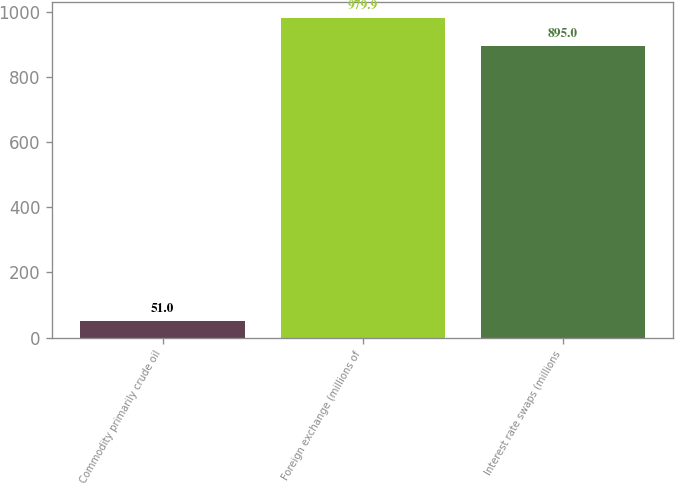Convert chart. <chart><loc_0><loc_0><loc_500><loc_500><bar_chart><fcel>Commodity primarily crude oil<fcel>Foreign exchange (millions of<fcel>Interest rate swaps (millions<nl><fcel>51<fcel>979.9<fcel>895<nl></chart> 